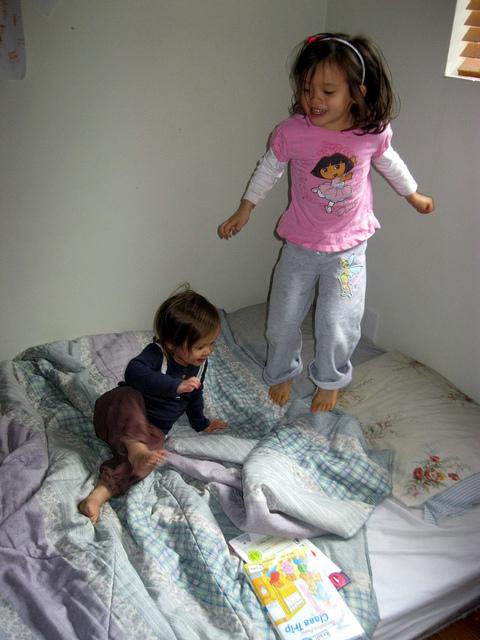What does the girl have around her neck?
Concise answer only. Nothing. How many girls are jumping on the bed?
Quick response, please. 1. Is the girls wearing bangles?
Concise answer only. No. Do the girls look like sisters?
Concise answer only. Yes. Are these girls in a kitchen?
Concise answer only. No. What is the girl holding?
Quick response, please. Nothing. How are these children likely related?
Write a very short answer. Siblings. What is the trim on the pink shirt?
Write a very short answer. White. 